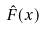<formula> <loc_0><loc_0><loc_500><loc_500>\hat { F } ( x )</formula> 